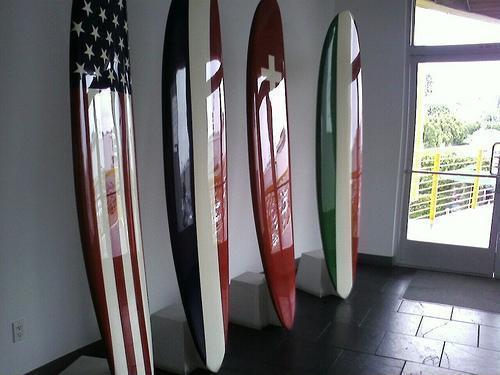What theme seems to have inspired the painting of the surfboards?
Indicate the correct response by choosing from the four available options to answer the question.
Options: Countries, sports, cars, superheroes. Countries. 